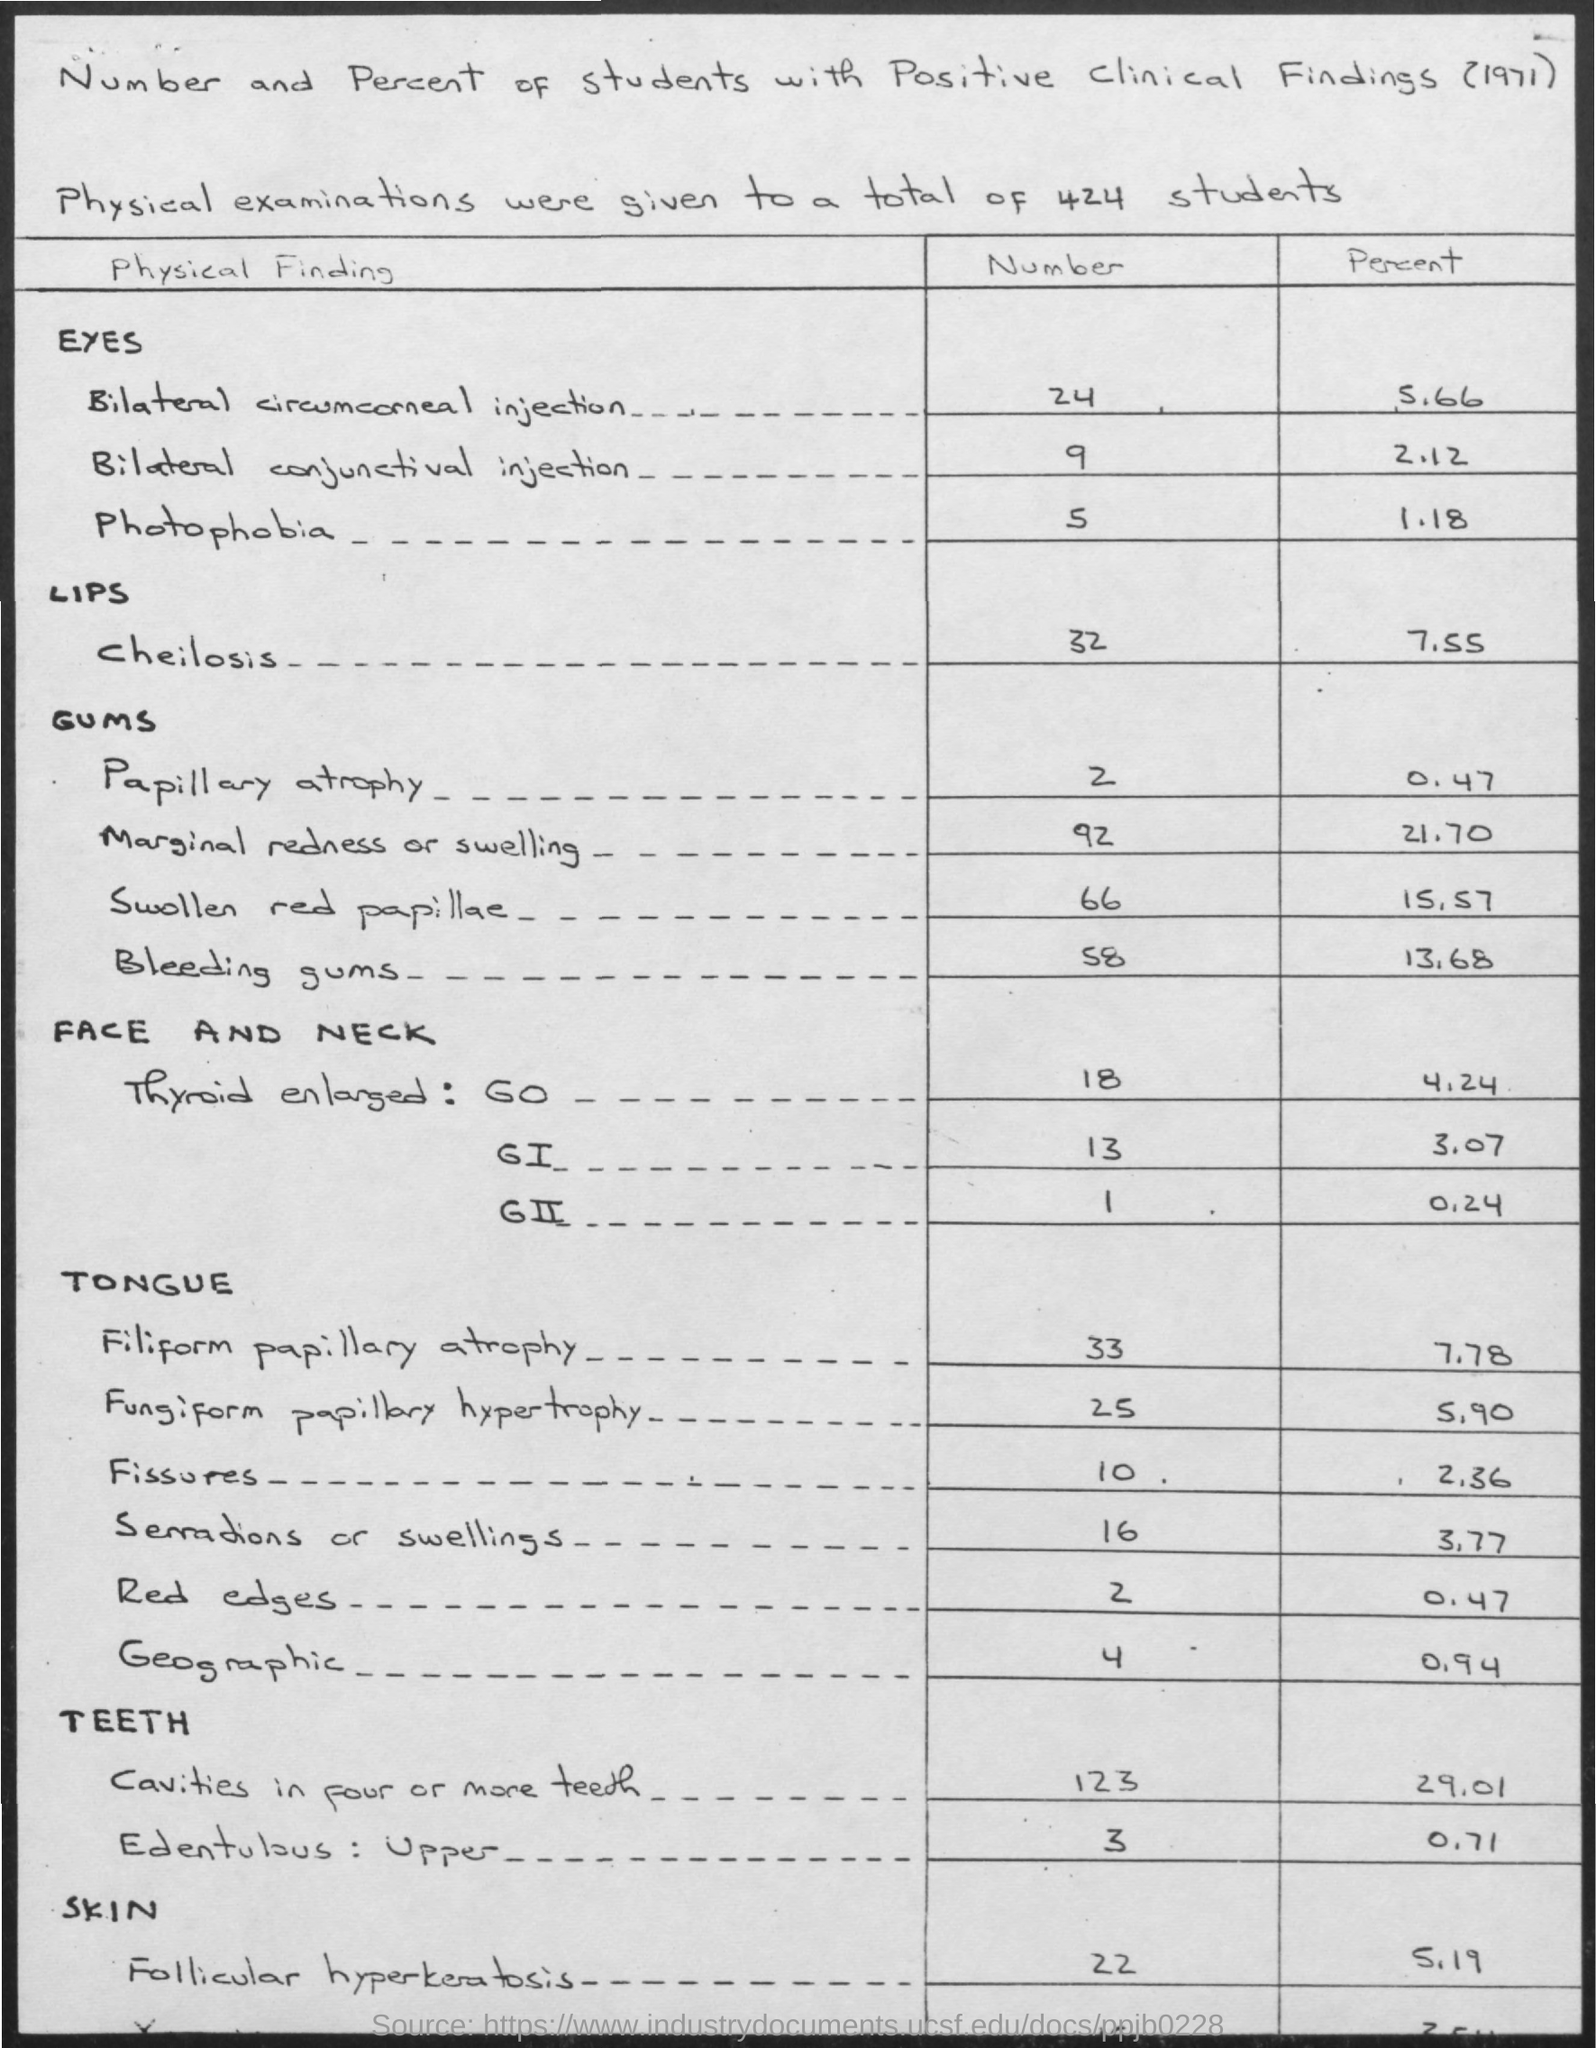List a handful of essential elements in this visual. There are 424 students. The year mentioned in the document is 1971. 